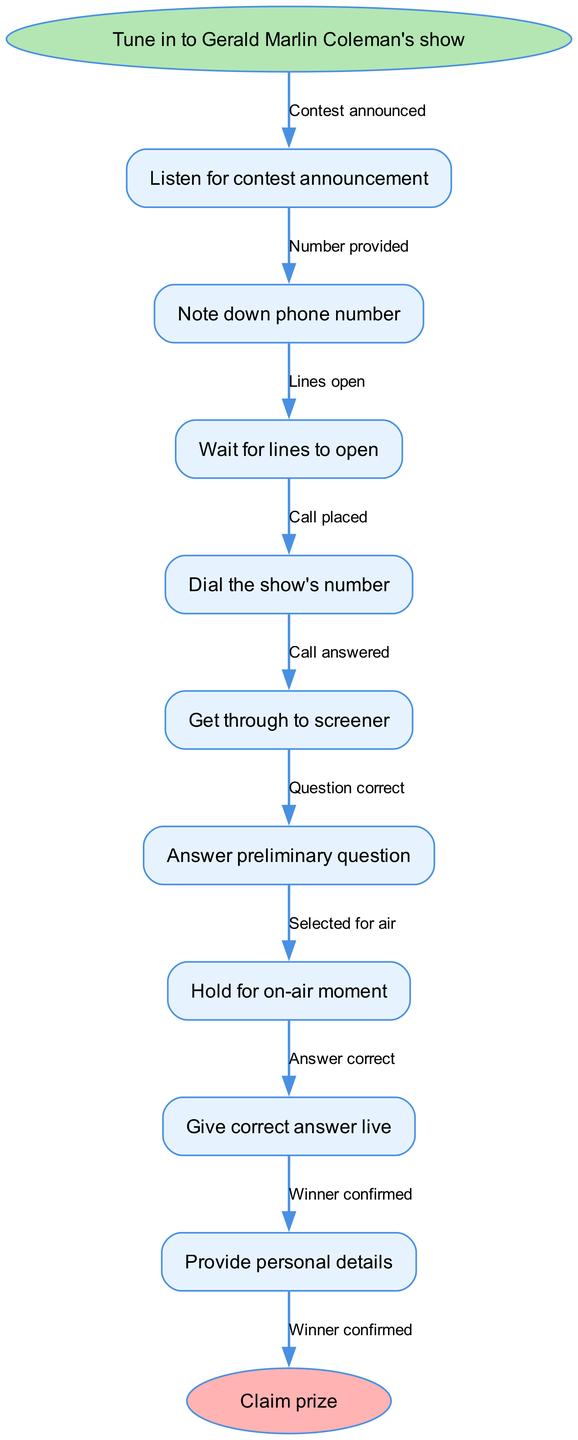What is the first step in the contest participation? The flow chart indicates that the first step is to "Tune in to Gerald Marlin Coleman's show." This is represented as the starting node.
Answer: Tune in to Gerald Marlin Coleman's show How many nodes are there in the flow chart? The flow chart has a total of 10 nodes, including the start and end nodes. This can be counted from the list of nodes provided.
Answer: 10 What do you do after you get through to the screener? After getting through to the screener, the next step is to "Answer preliminary question." This is the direct connection from the screener node in the flow chart.
Answer: Answer preliminary question What is the relationship between "Give correct answer live" and "Hold for on-air moment"? The relationship is sequential; after "Hold for on-air moment" is completed, the next step is to "Give correct answer live." This is indicated by the flow direction in the chart.
Answer: Sequential What is the final action in the contest participation process? The final action, which is represented at the end of the flow diagram, is to "Claim prize." This indicates the conclusion of the participation process.
Answer: Claim prize What must you do just before dialing the show's number? Before dialing the show's number, you must "Wait for lines to open." This step is positioned just before making the call in the flow of the process.
Answer: Wait for lines to open Which node directly follows "Get through to screener"? The node that directly follows "Get through to screener" is "Answer preliminary question." This is shown by the connecting edge in the flow chart.
Answer: Answer preliminary question How does one get selected for air? One gets selected for air by answering the preliminary question correctly, as indicated by the flow connection between "Answer preliminary question" and "Hold for on-air moment."
Answer: By answering correctly What is the relationship between "Give correct answer live" and the final step? The relationship is causal; giving the correct answer live leads to the final step of claiming a prize. This progression is shown by the connection in the diagram.
Answer: Causal 